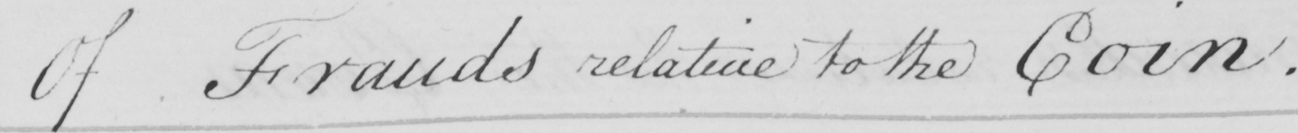What text is written in this handwritten line? Of Frauds relative to the Coin . 